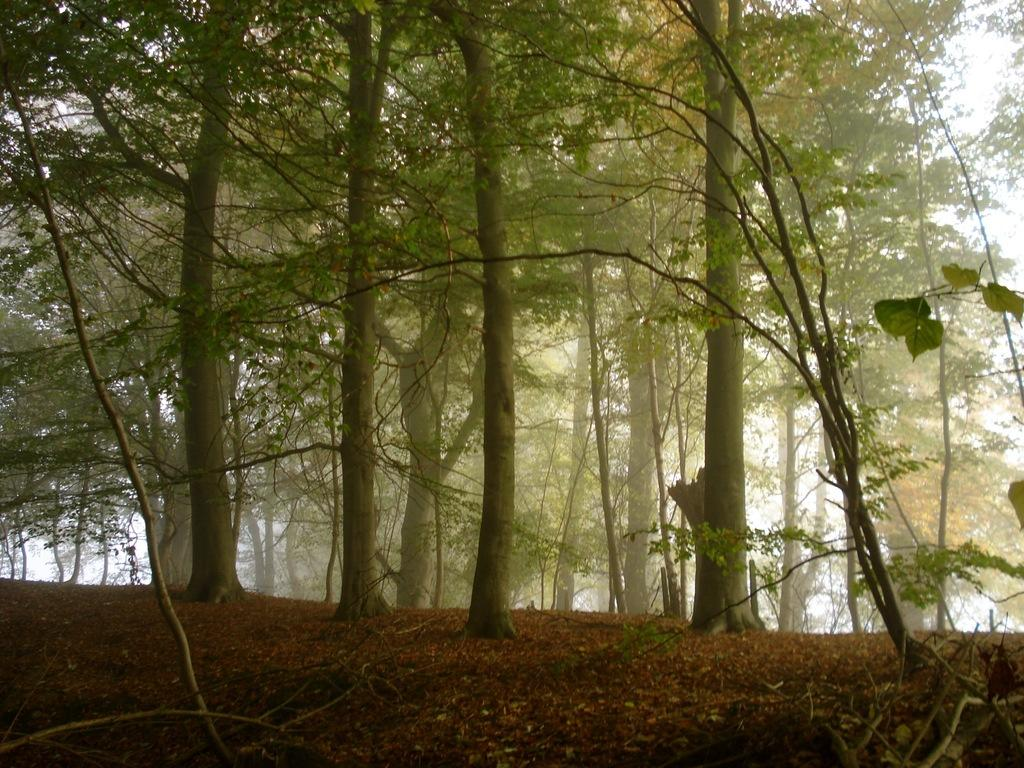What can be seen at the bottom of the image? The ground is visible in the image. What type of vegetation is present in the image? There are trees in the image. What is visible in the distance in the image? The sky is visible in the background of the image. What type of fowl can be seen wearing a boot in the image? There is no fowl or boot present in the image. What time is indicated by the watch in the image? There is no watch present in the image. 